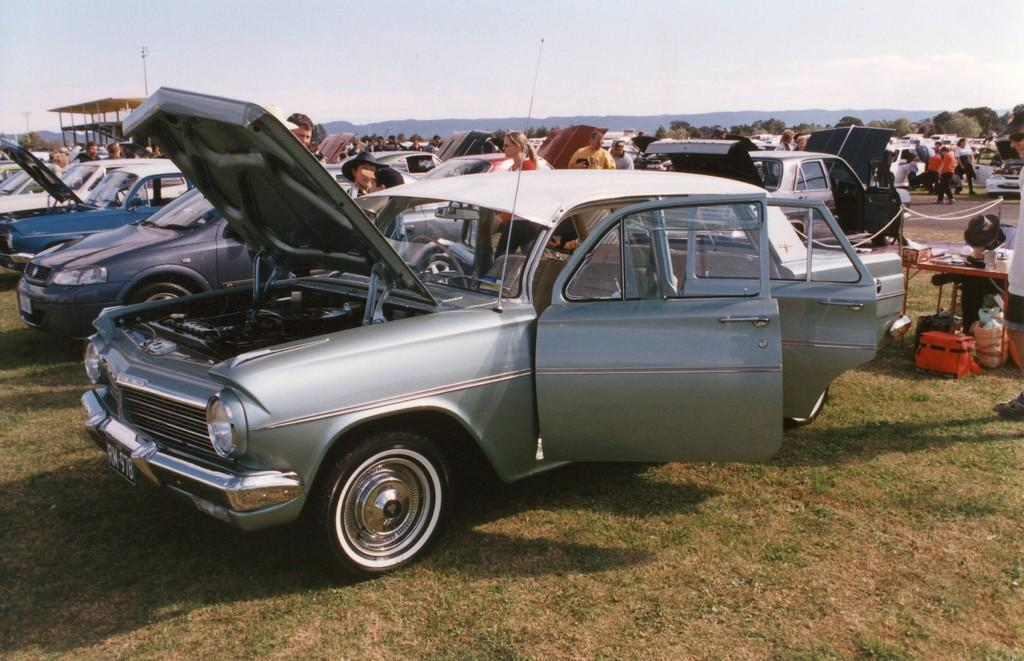How many people are in the image? There is a group of people in the image, but the exact number is not specified. What else can be seen in the image besides the group of people? There are vehicles, a table, a shelter, bags on the grass, some objects, trees, mountains, and the sky visible in the background of the image. Can you describe the setting of the image? The image appears to be set outdoors, with trees and mountains in the background, and a grassy area where the bags are placed. What might the people be using the table for in the image? The table could be used for various purposes, such as serving food or holding items, but this is not explicitly stated in the facts. How does the judge in the image use their grip to control the stick? There is no judge or stick present in the image. 